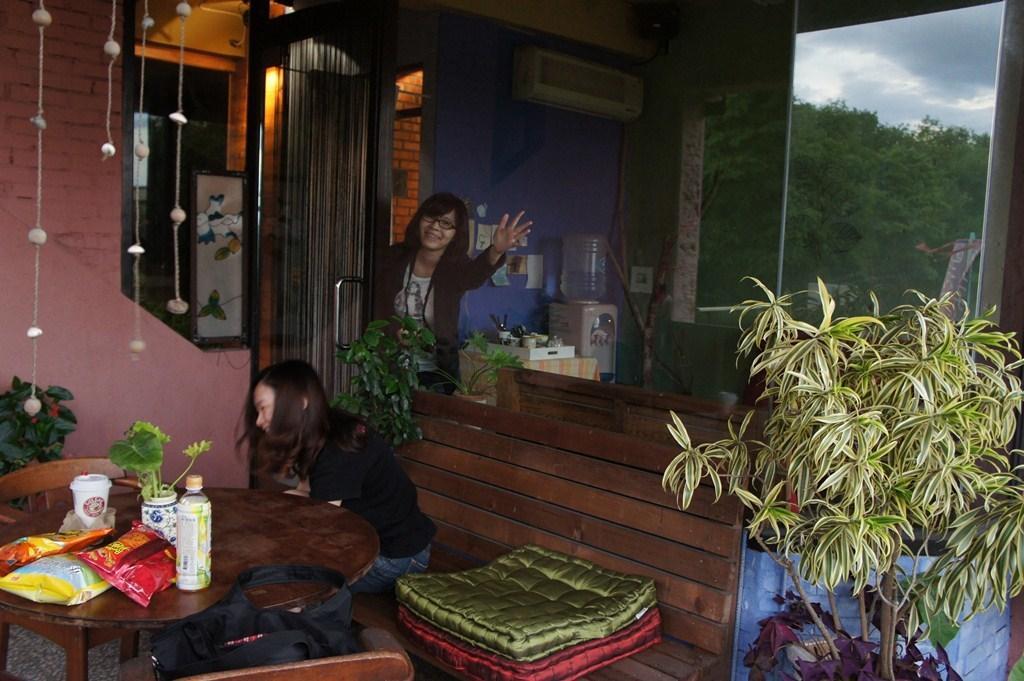Can you describe this image briefly? In this picture we can see two woman one is sitting on bench and other is standing and smiling and in front of them we can see table and on table we have chips packet, bottle, vase plant in it, glass an din background we can see wall, frame, curtain, AC, tray, trees, window. 